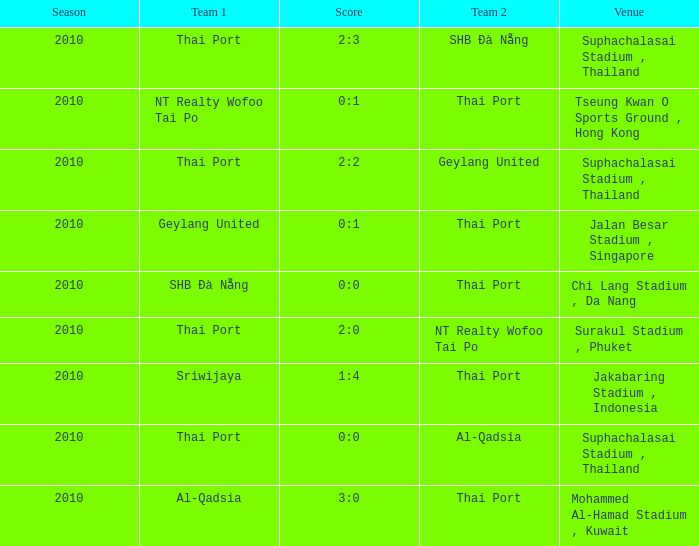What was the score for the game in which Al-Qadsia was Team 2? 0:0. 